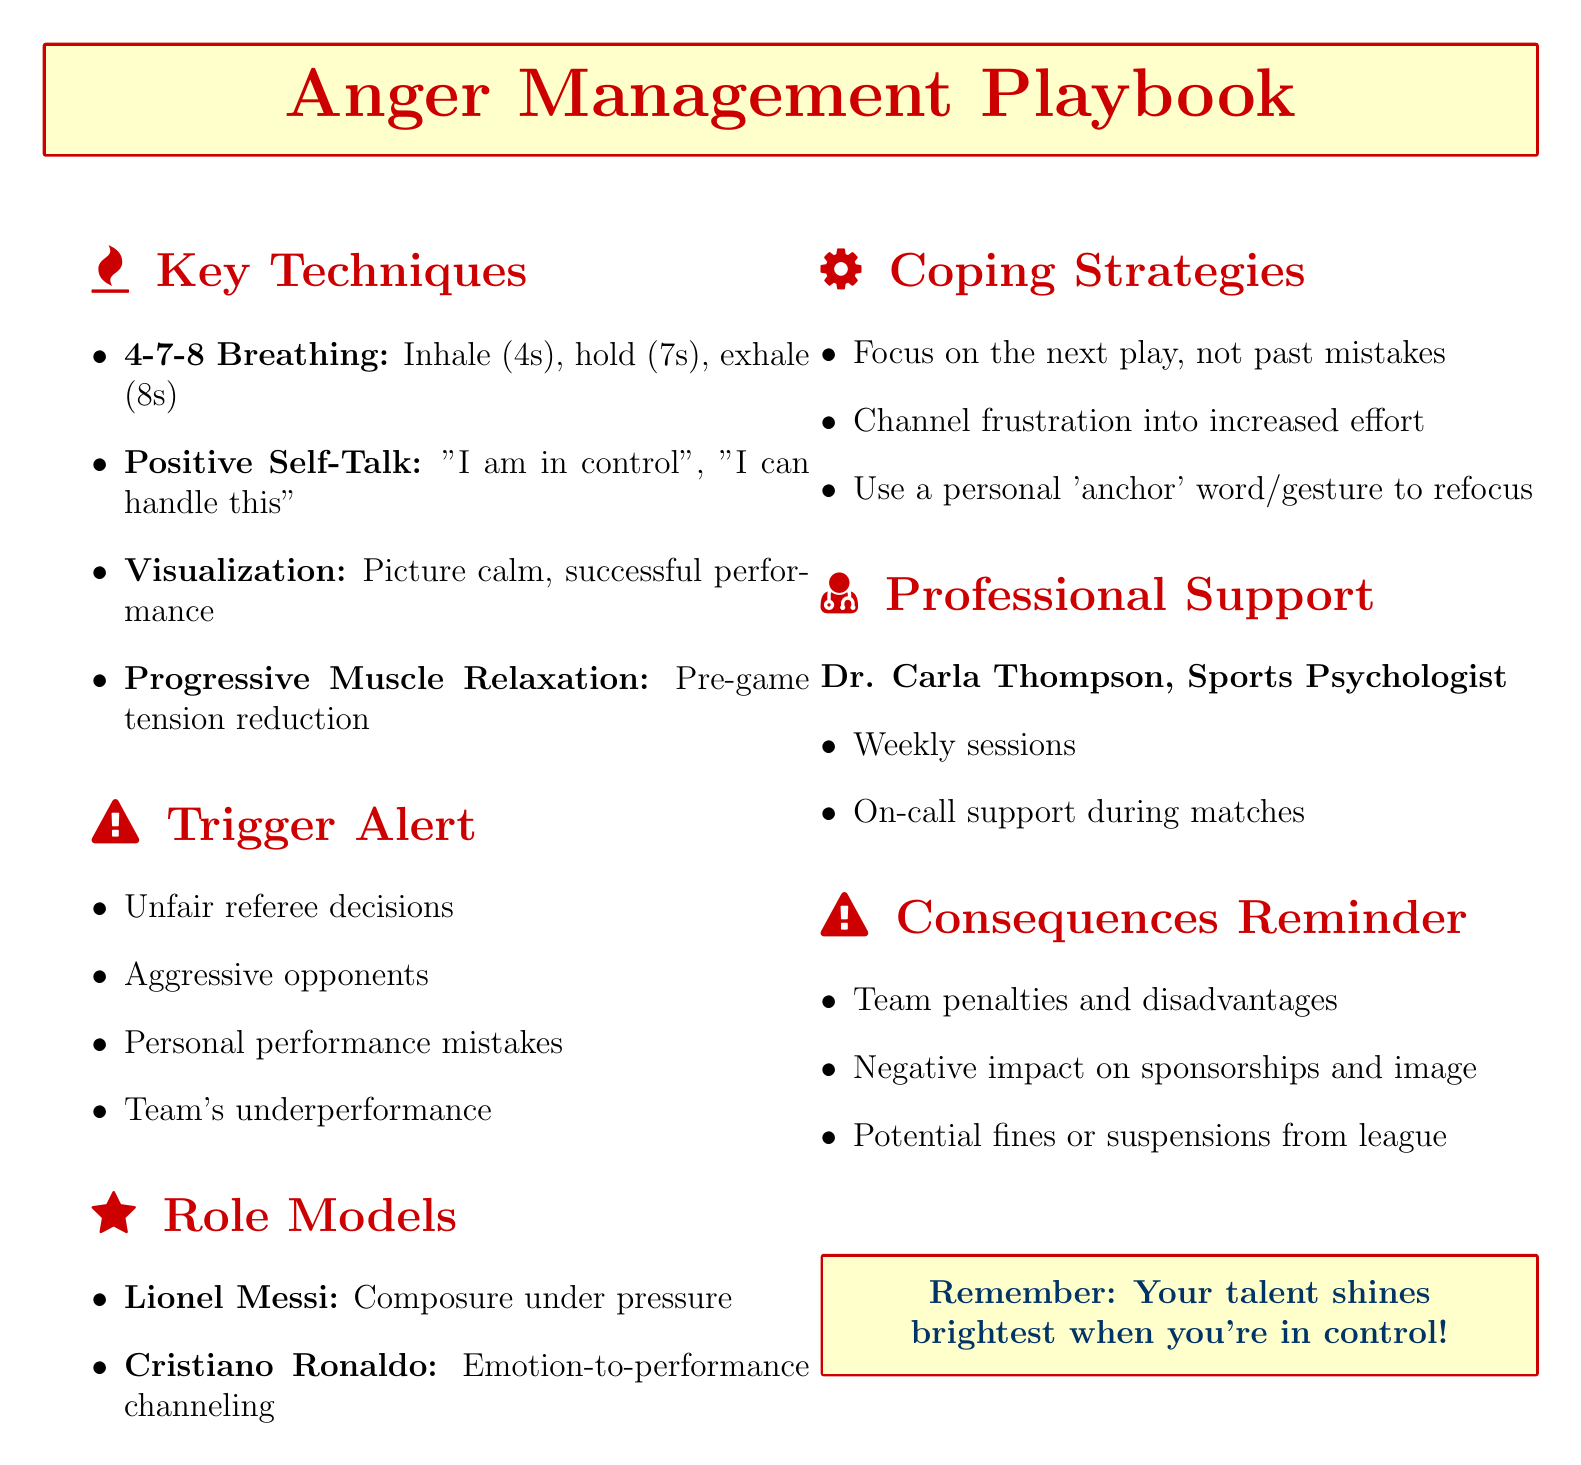What is the title of the document? The title is explicitly stated at the beginning of the document as "Anger Management Techniques for On-Field Control."
Answer: Anger Management Techniques for On-Field Control How many key techniques are listed? The document lists four specific techniques for anger management under the key points section.
Answer: 4 What is the technique involving breathing? The specific technique mentioned is "4-7-8 Breathing."
Answer: 4-7-8 Breathing Who is the professional support mentioned? The document identifies a sports psychologist named Dr. Carla Thompson for professional support.
Answer: Dr. Carla Thompson What is one trigger for anger identified in the document? The document includes multiple triggers; one example is "Unfair referee decisions."
Answer: Unfair referee decisions Which famous player is noted for maintaining composure under pressure? The document names Lionel Messi as a role model for this trait.
Answer: Lionel Messi What coping strategy involves focusing on future plays? The document suggests to "Focus on the next play instead of dwelling on mistakes."
Answer: Focus on the next play What are the potential consequences listed for on-field outbursts? One consequence mentioned is "Team penalties and disadvantages."
Answer: Team penalties and disadvantages What is a recommended phrase for positive self-talk? One recommended affirmation is "I am in control."
Answer: I am in control 